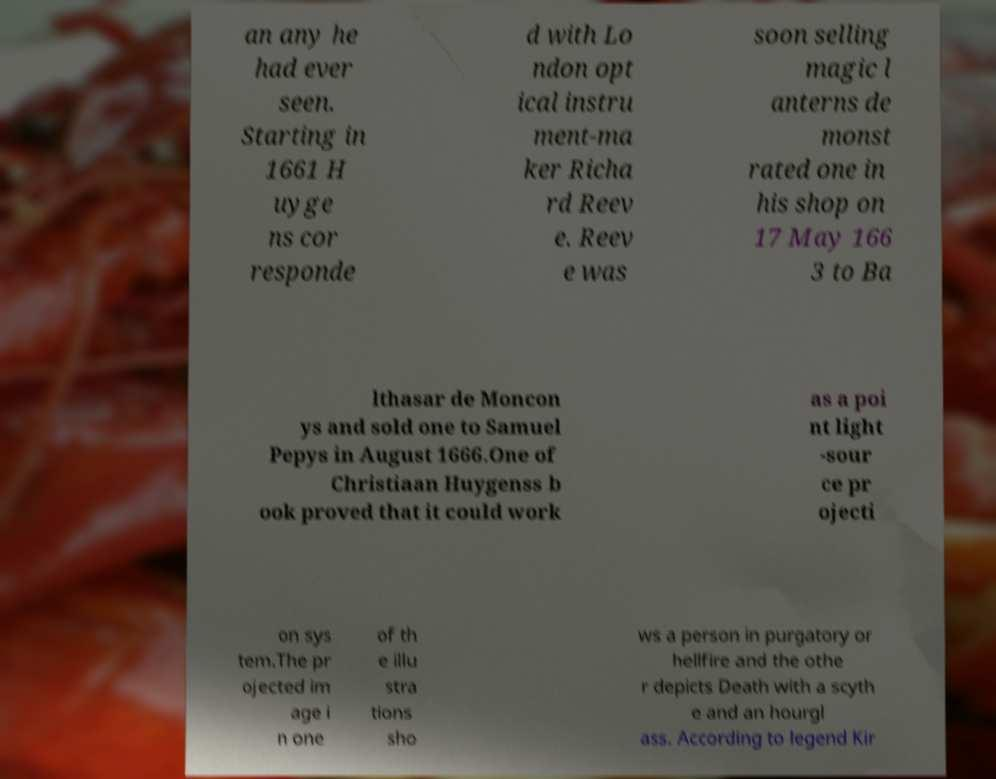Could you extract and type out the text from this image? an any he had ever seen. Starting in 1661 H uyge ns cor responde d with Lo ndon opt ical instru ment-ma ker Richa rd Reev e. Reev e was soon selling magic l anterns de monst rated one in his shop on 17 May 166 3 to Ba lthasar de Moncon ys and sold one to Samuel Pepys in August 1666.One of Christiaan Huygenss b ook proved that it could work as a poi nt light -sour ce pr ojecti on sys tem.The pr ojected im age i n one of th e illu stra tions sho ws a person in purgatory or hellfire and the othe r depicts Death with a scyth e and an hourgl ass. According to legend Kir 